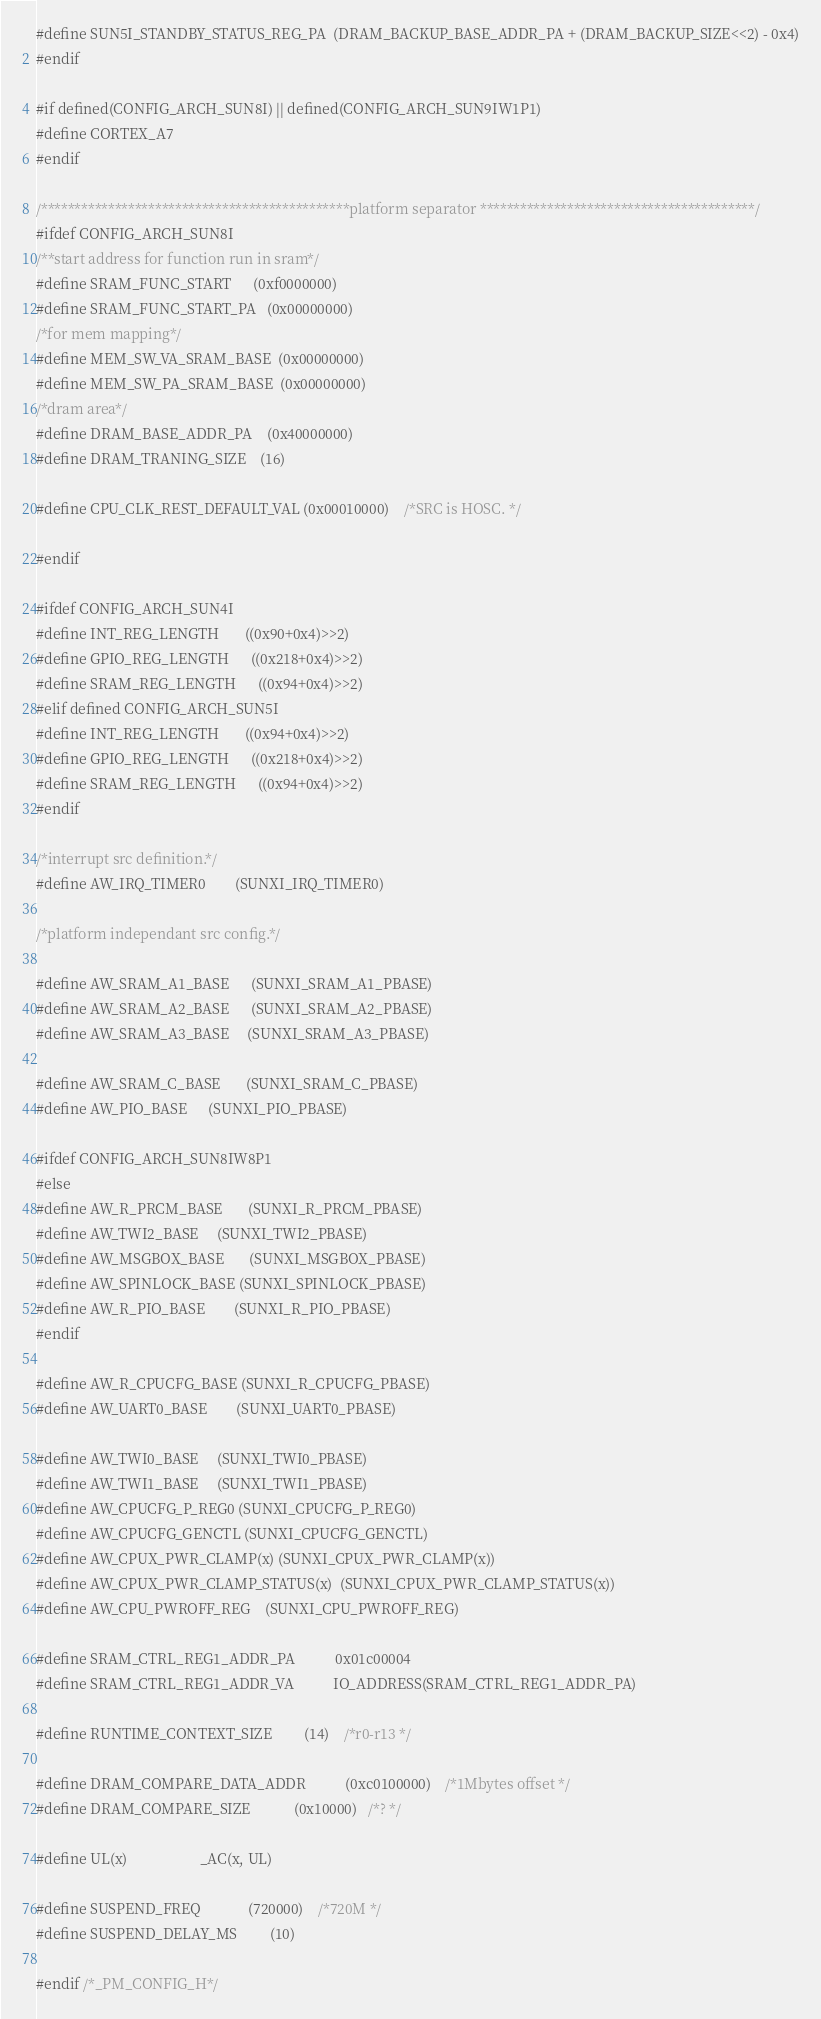Convert code to text. <code><loc_0><loc_0><loc_500><loc_500><_C_>#define SUN5I_STANDBY_STATUS_REG_PA	(DRAM_BACKUP_BASE_ADDR_PA + (DRAM_BACKUP_SIZE<<2) - 0x4)
#endif

#if defined(CONFIG_ARCH_SUN8I) || defined(CONFIG_ARCH_SUN9IW1P1)
#define CORTEX_A7
#endif

/**********************************************platform separator *****************************************/
#ifdef CONFIG_ARCH_SUN8I
/**start address for function run in sram*/
#define SRAM_FUNC_START		(0xf0000000)
#define SRAM_FUNC_START_PA	(0x00000000)
/*for mem mapping*/
#define MEM_SW_VA_SRAM_BASE	(0x00000000)
#define MEM_SW_PA_SRAM_BASE	(0x00000000)
/*dram area*/
#define DRAM_BASE_ADDR_PA	(0x40000000)
#define DRAM_TRANING_SIZE	(16)

#define CPU_CLK_REST_DEFAULT_VAL	(0x00010000)	/*SRC is HOSC. */

#endif

#ifdef CONFIG_ARCH_SUN4I
#define INT_REG_LENGTH		((0x90+0x4)>>2)
#define GPIO_REG_LENGTH		((0x218+0x4)>>2)
#define SRAM_REG_LENGTH		((0x94+0x4)>>2)
#elif defined CONFIG_ARCH_SUN5I
#define INT_REG_LENGTH		((0x94+0x4)>>2)
#define GPIO_REG_LENGTH		((0x218+0x4)>>2)
#define SRAM_REG_LENGTH		((0x94+0x4)>>2)
#endif

/*interrupt src definition.*/
#define AW_IRQ_TIMER0		(SUNXI_IRQ_TIMER0)

/*platform independant src config.*/

#define AW_SRAM_A1_BASE		(SUNXI_SRAM_A1_PBASE)
#define AW_SRAM_A2_BASE		(SUNXI_SRAM_A2_PBASE)
#define AW_SRAM_A3_BASE     (SUNXI_SRAM_A3_PBASE)

#define AW_SRAM_C_BASE		(SUNXI_SRAM_C_PBASE)
#define AW_PIO_BASE		(SUNXI_PIO_PBASE)

#ifdef CONFIG_ARCH_SUN8IW8P1
#else
#define AW_R_PRCM_BASE		(SUNXI_R_PRCM_PBASE)
#define AW_TWI2_BASE		(SUNXI_TWI2_PBASE)
#define AW_MSGBOX_BASE		(SUNXI_MSGBOX_PBASE)
#define AW_SPINLOCK_BASE	(SUNXI_SPINLOCK_PBASE)
#define AW_R_PIO_BASE		(SUNXI_R_PIO_PBASE)
#endif

#define AW_R_CPUCFG_BASE	(SUNXI_R_CPUCFG_PBASE)
#define AW_UART0_BASE		(SUNXI_UART0_PBASE)

#define AW_TWI0_BASE		(SUNXI_TWI0_PBASE)
#define AW_TWI1_BASE		(SUNXI_TWI1_PBASE)
#define AW_CPUCFG_P_REG0	(SUNXI_CPUCFG_P_REG0)
#define AW_CPUCFG_GENCTL	(SUNXI_CPUCFG_GENCTL)
#define AW_CPUX_PWR_CLAMP(x)	(SUNXI_CPUX_PWR_CLAMP(x))
#define AW_CPUX_PWR_CLAMP_STATUS(x)	(SUNXI_CPUX_PWR_CLAMP_STATUS(x))
#define AW_CPU_PWROFF_REG	(SUNXI_CPU_PWROFF_REG)

#define SRAM_CTRL_REG1_ADDR_PA			0x01c00004
#define SRAM_CTRL_REG1_ADDR_VA			IO_ADDRESS(SRAM_CTRL_REG1_ADDR_PA)

#define RUNTIME_CONTEXT_SIZE			(14)	/*r0-r13 */

#define DRAM_COMPARE_DATA_ADDR			(0xc0100000)	/*1Mbytes offset */
#define DRAM_COMPARE_SIZE			(0x10000)	/*? */

#define UL(x)					_AC(x, UL)

#define SUSPEND_FREQ				(720000)	/*720M */
#define SUSPEND_DELAY_MS			(10)

#endif /*_PM_CONFIG_H*/
</code> 